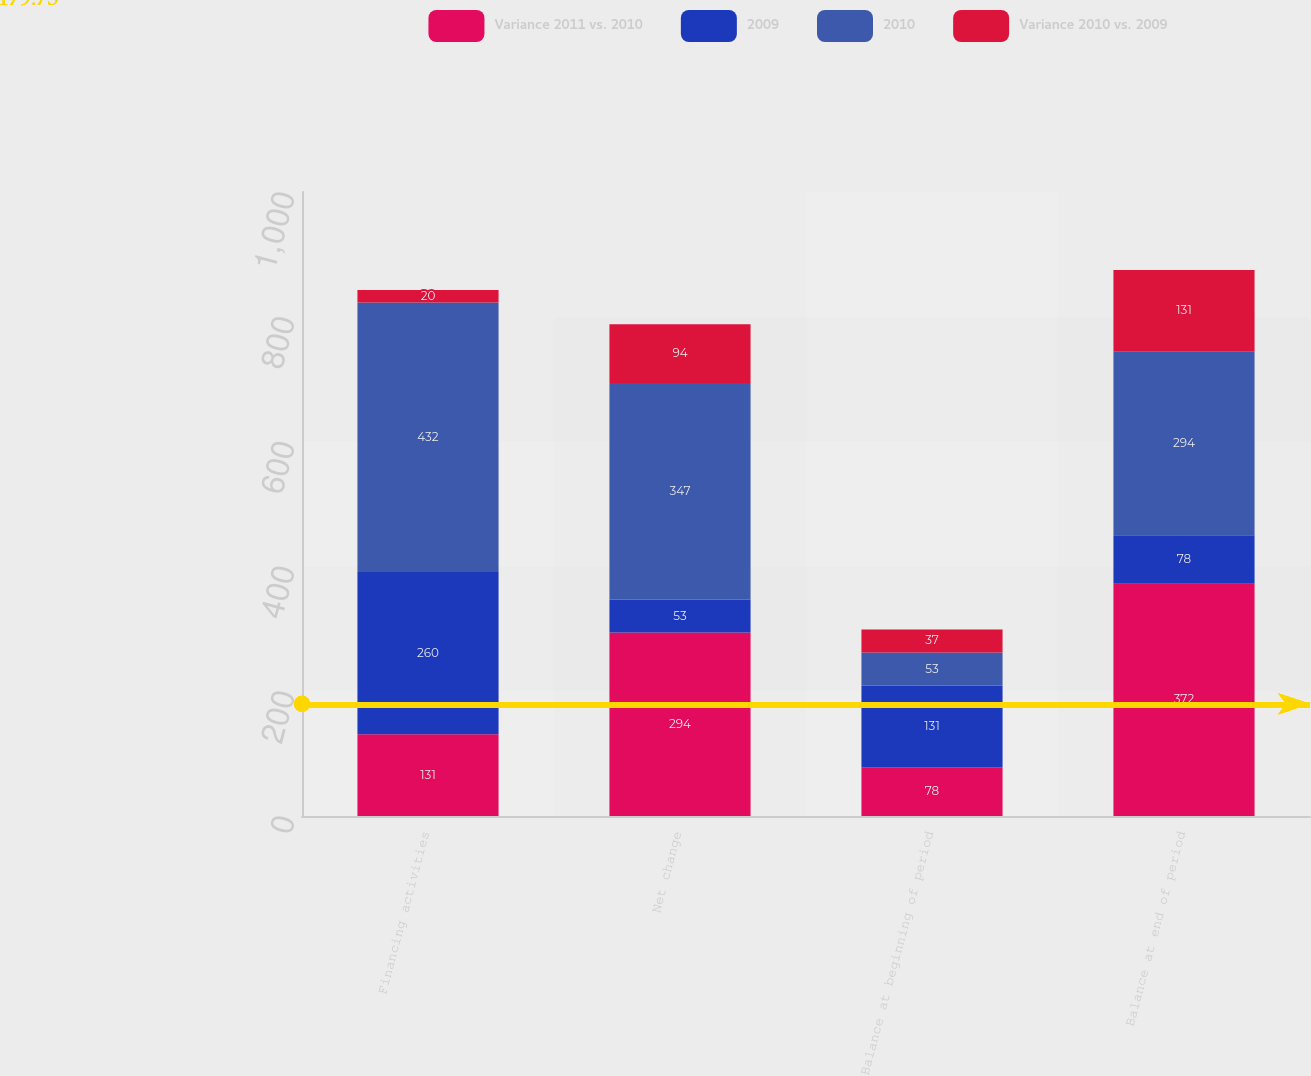Convert chart to OTSL. <chart><loc_0><loc_0><loc_500><loc_500><stacked_bar_chart><ecel><fcel>Financing activities<fcel>Net change<fcel>Balance at beginning of period<fcel>Balance at end of period<nl><fcel>Variance 2011 vs. 2010<fcel>131<fcel>294<fcel>78<fcel>372<nl><fcel>2009<fcel>260<fcel>53<fcel>131<fcel>78<nl><fcel>2010<fcel>432<fcel>347<fcel>53<fcel>294<nl><fcel>Variance 2010 vs. 2009<fcel>20<fcel>94<fcel>37<fcel>131<nl></chart> 